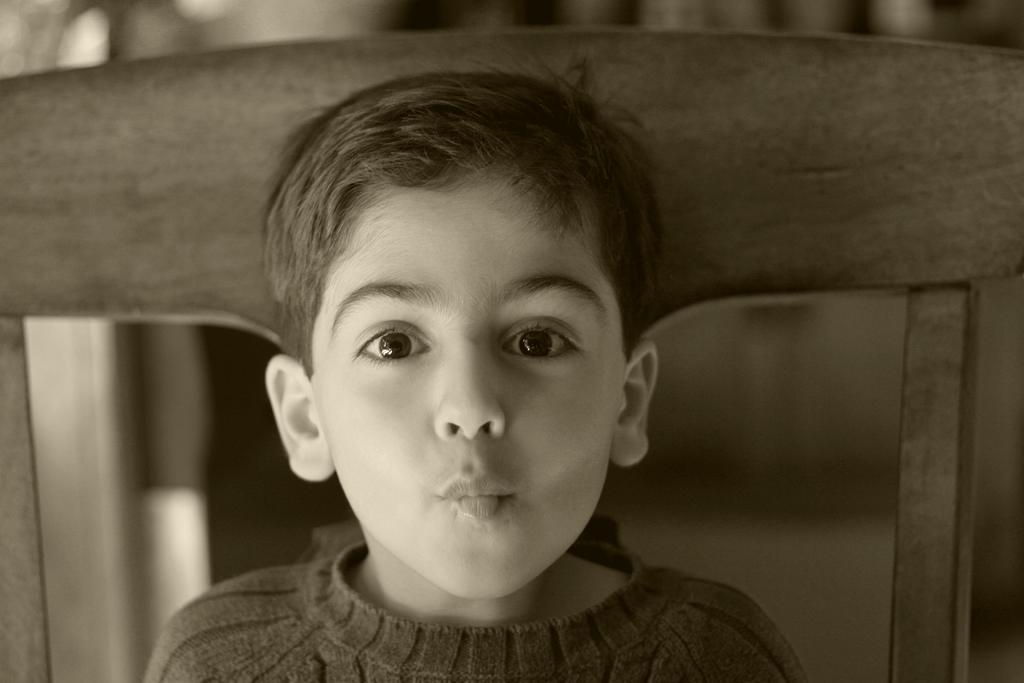Who is the main subject in the image? There is a boy in the image. What is the boy doing in the image? The boy is sitting on a chair. What is the color scheme of the image? The image is black and white. What time does the boy's sister leaving a note for him in the image? There is no mention of a sister or a note in the image, so we cannot answer this question. 